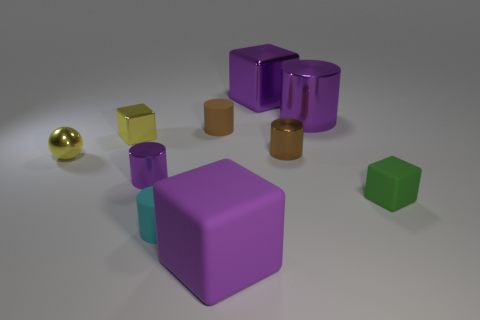Subtract all cyan cylinders. How many cylinders are left? 4 Subtract all cyan cylinders. How many cylinders are left? 4 Subtract all cyan cylinders. Subtract all red blocks. How many cylinders are left? 4 Subtract all blocks. How many objects are left? 6 Add 7 metal balls. How many metal balls exist? 8 Subtract 0 purple spheres. How many objects are left? 10 Subtract all large matte blocks. Subtract all brown objects. How many objects are left? 7 Add 6 big rubber blocks. How many big rubber blocks are left? 7 